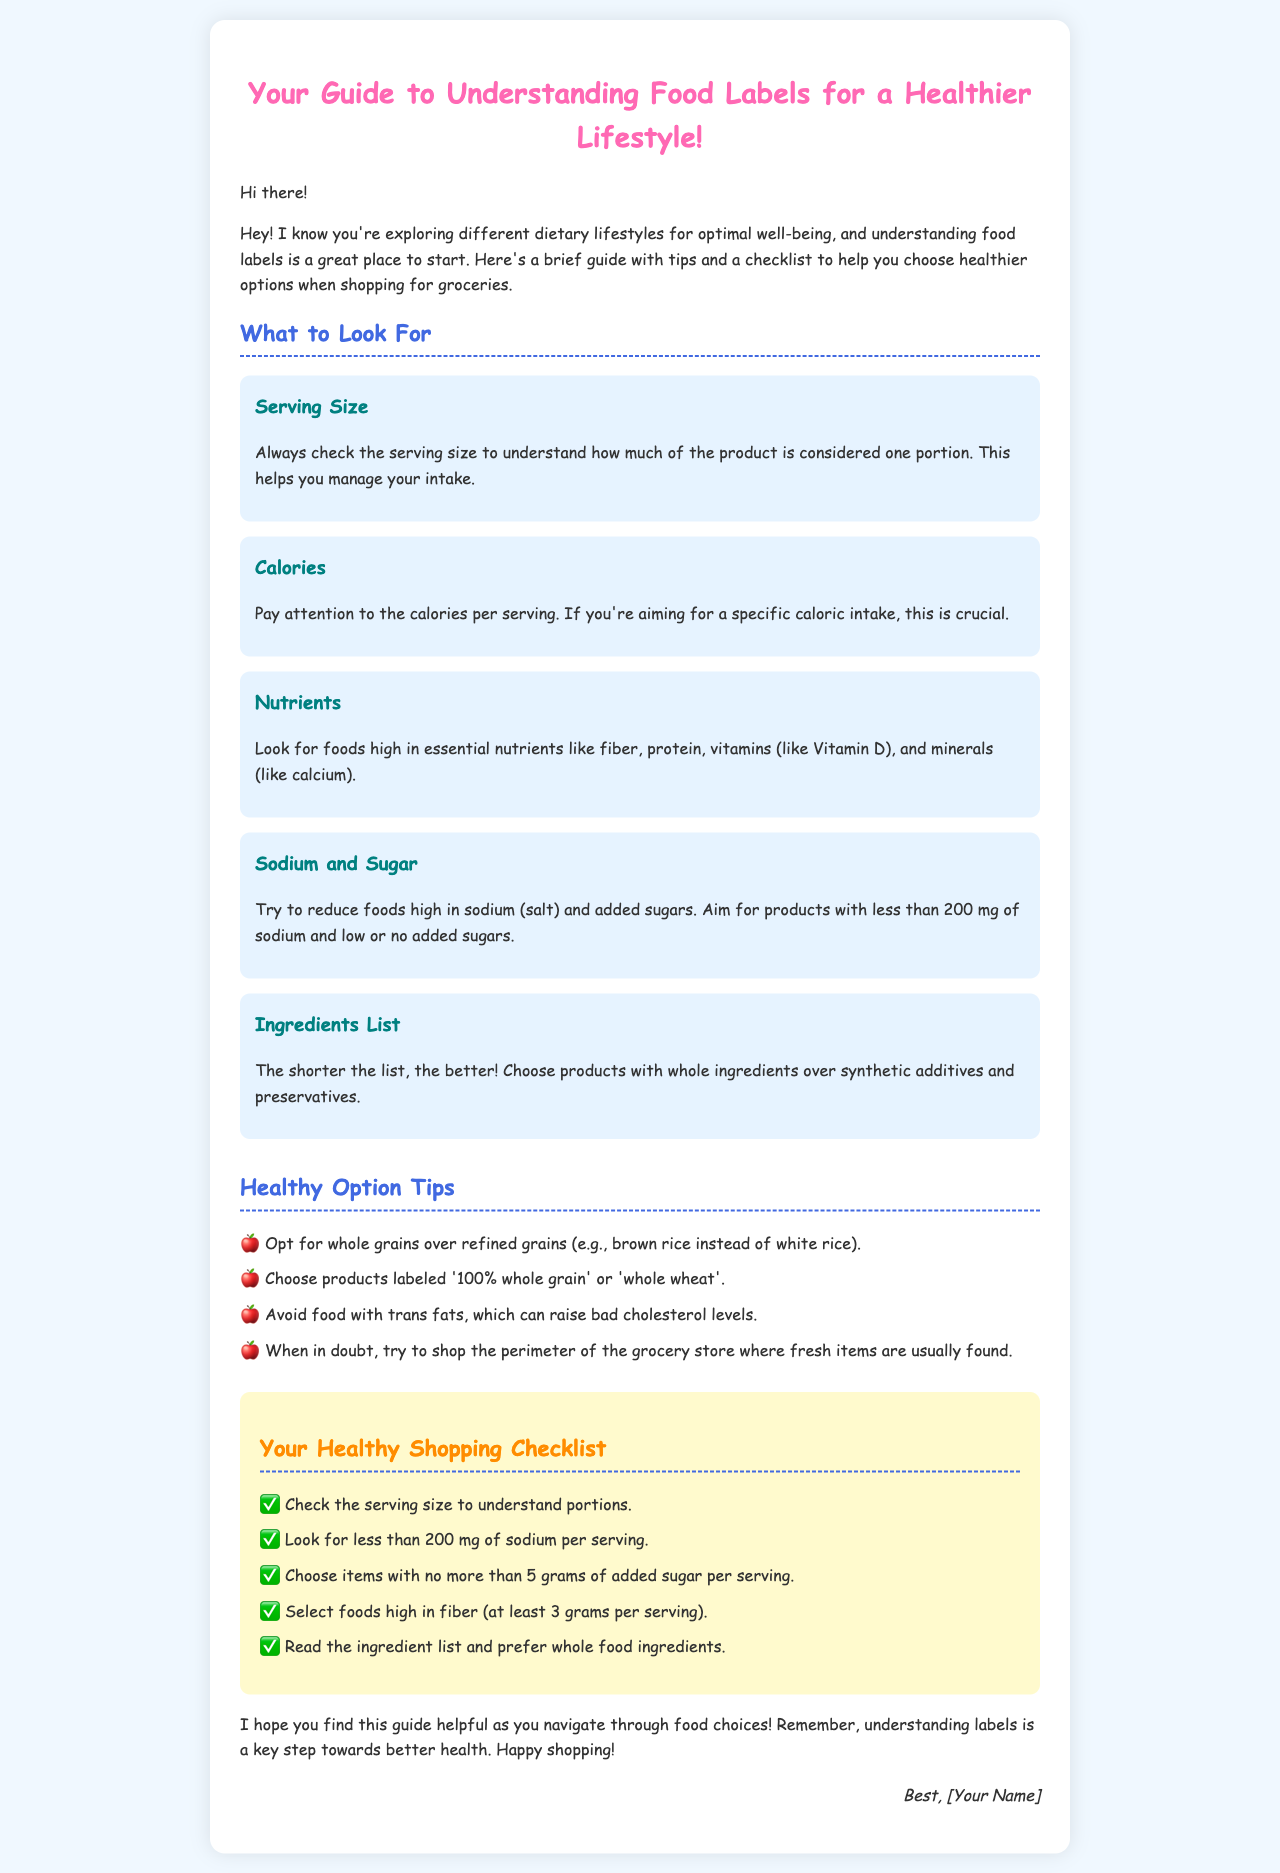What is the title of the guide? The title is displayed prominently at the top of the document and is "Your Guide to Understanding Food Labels for a Healthier Lifestyle!"
Answer: Your Guide to Understanding Food Labels for a Healthier Lifestyle! What should you check regarding sodium? The checklist recommends looking for less than 200 mg of sodium per serving in food products.
Answer: less than 200 mg What nutrient should be at least 3 grams per serving? The checklist advises selecting foods high in fiber, which should meet the specified amount.
Answer: fiber What ingredient type is recommended in healthier options? The document states to prefer whole food ingredients over synthetic additives.
Answer: whole food ingredients How many tips are listed under Healthy Option Tips? There are four specific tips provided in the section for healthy options.
Answer: four What is the background color of the document? The background color specified in the styling of the document is light blue or similar, which creates a visually pleasing layout.
Answer: #f0f8ff What type of font is used in the document? The type of font as stated in the style section is 'Comic Sans MS', which is casual and approachable for readers.
Answer: Comic Sans MS What is the signature section meant to convey? The signature typically presents a personal touch, concluding the message with the sender's name.
Answer: sender's name 